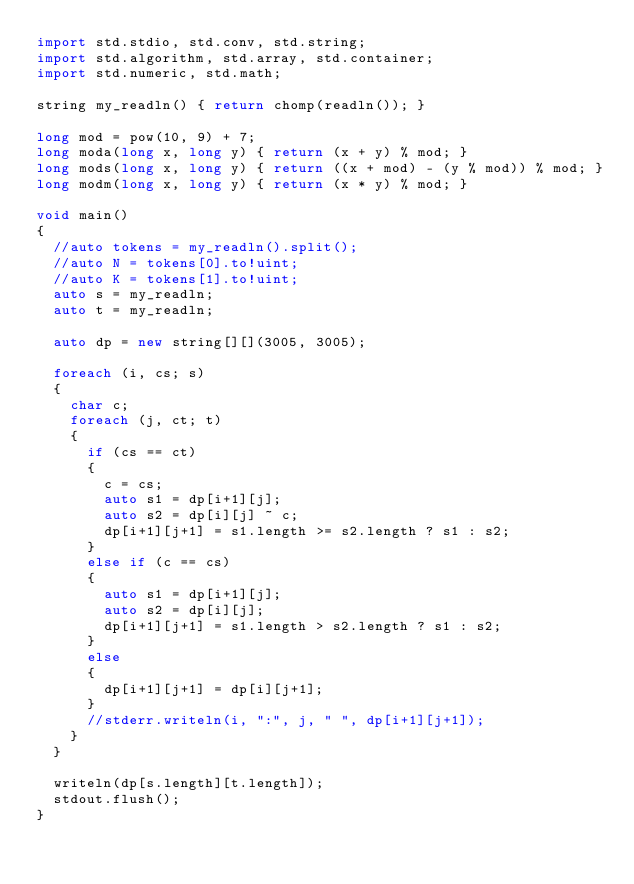<code> <loc_0><loc_0><loc_500><loc_500><_D_>import std.stdio, std.conv, std.string;
import std.algorithm, std.array, std.container;
import std.numeric, std.math;

string my_readln() { return chomp(readln()); }

long mod = pow(10, 9) + 7;
long moda(long x, long y) { return (x + y) % mod; }
long mods(long x, long y) { return ((x + mod) - (y % mod)) % mod; }
long modm(long x, long y) { return (x * y) % mod; }

void main()
{
	//auto tokens = my_readln().split();
	//auto N = tokens[0].to!uint;
	//auto K = tokens[1].to!uint;
	auto s = my_readln;
	auto t = my_readln;

	auto dp = new string[][](3005, 3005);

	foreach (i, cs; s)
	{
		char c;
		foreach (j, ct; t)
		{
			if (cs == ct)
			{
				c = cs;
				auto s1 = dp[i+1][j];
				auto s2 = dp[i][j] ~ c;
				dp[i+1][j+1] = s1.length >= s2.length ? s1 : s2;
			}
			else if (c == cs)
			{
				auto s1 = dp[i+1][j];
				auto s2 = dp[i][j];
				dp[i+1][j+1] = s1.length > s2.length ? s1 : s2;
			}
			else
			{
				dp[i+1][j+1] = dp[i][j+1];
			}
			//stderr.writeln(i, ":", j, " ", dp[i+1][j+1]);
		}
	}

	writeln(dp[s.length][t.length]);
	stdout.flush();
}</code> 